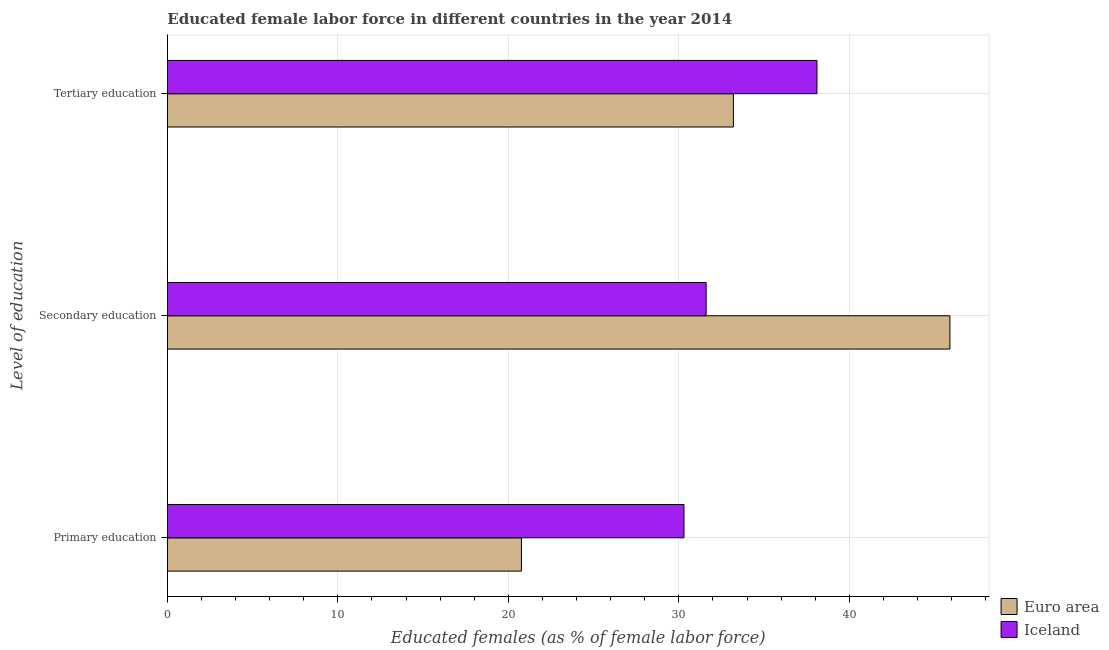How many different coloured bars are there?
Provide a short and direct response. 2. How many groups of bars are there?
Your answer should be compact. 3. How many bars are there on the 3rd tick from the bottom?
Ensure brevity in your answer.  2. What is the label of the 2nd group of bars from the top?
Offer a terse response. Secondary education. What is the percentage of female labor force who received secondary education in Iceland?
Your response must be concise. 31.6. Across all countries, what is the maximum percentage of female labor force who received tertiary education?
Keep it short and to the point. 38.1. Across all countries, what is the minimum percentage of female labor force who received primary education?
Make the answer very short. 20.77. In which country was the percentage of female labor force who received tertiary education minimum?
Make the answer very short. Euro area. What is the total percentage of female labor force who received secondary education in the graph?
Give a very brief answer. 77.5. What is the difference between the percentage of female labor force who received tertiary education in Iceland and that in Euro area?
Your answer should be very brief. 4.9. What is the difference between the percentage of female labor force who received primary education in Euro area and the percentage of female labor force who received tertiary education in Iceland?
Your response must be concise. -17.33. What is the average percentage of female labor force who received primary education per country?
Offer a very short reply. 25.53. What is the difference between the percentage of female labor force who received secondary education and percentage of female labor force who received tertiary education in Euro area?
Offer a very short reply. 12.7. What is the ratio of the percentage of female labor force who received primary education in Iceland to that in Euro area?
Keep it short and to the point. 1.46. What is the difference between the highest and the second highest percentage of female labor force who received secondary education?
Provide a short and direct response. 14.3. What is the difference between the highest and the lowest percentage of female labor force who received primary education?
Give a very brief answer. 9.53. In how many countries, is the percentage of female labor force who received tertiary education greater than the average percentage of female labor force who received tertiary education taken over all countries?
Your answer should be very brief. 1. What does the 2nd bar from the top in Primary education represents?
Make the answer very short. Euro area. What does the 2nd bar from the bottom in Tertiary education represents?
Offer a terse response. Iceland. Is it the case that in every country, the sum of the percentage of female labor force who received primary education and percentage of female labor force who received secondary education is greater than the percentage of female labor force who received tertiary education?
Your answer should be very brief. Yes. Are all the bars in the graph horizontal?
Provide a short and direct response. Yes. How many countries are there in the graph?
Give a very brief answer. 2. Does the graph contain grids?
Keep it short and to the point. Yes. How many legend labels are there?
Offer a very short reply. 2. What is the title of the graph?
Provide a succinct answer. Educated female labor force in different countries in the year 2014. What is the label or title of the X-axis?
Offer a very short reply. Educated females (as % of female labor force). What is the label or title of the Y-axis?
Offer a terse response. Level of education. What is the Educated females (as % of female labor force) in Euro area in Primary education?
Provide a short and direct response. 20.77. What is the Educated females (as % of female labor force) of Iceland in Primary education?
Keep it short and to the point. 30.3. What is the Educated females (as % of female labor force) of Euro area in Secondary education?
Provide a short and direct response. 45.9. What is the Educated females (as % of female labor force) of Iceland in Secondary education?
Give a very brief answer. 31.6. What is the Educated females (as % of female labor force) in Euro area in Tertiary education?
Your answer should be very brief. 33.2. What is the Educated females (as % of female labor force) of Iceland in Tertiary education?
Keep it short and to the point. 38.1. Across all Level of education, what is the maximum Educated females (as % of female labor force) in Euro area?
Your answer should be very brief. 45.9. Across all Level of education, what is the maximum Educated females (as % of female labor force) in Iceland?
Your answer should be compact. 38.1. Across all Level of education, what is the minimum Educated females (as % of female labor force) of Euro area?
Ensure brevity in your answer.  20.77. Across all Level of education, what is the minimum Educated females (as % of female labor force) of Iceland?
Give a very brief answer. 30.3. What is the total Educated females (as % of female labor force) in Euro area in the graph?
Keep it short and to the point. 99.87. What is the total Educated females (as % of female labor force) of Iceland in the graph?
Offer a terse response. 100. What is the difference between the Educated females (as % of female labor force) of Euro area in Primary education and that in Secondary education?
Your answer should be very brief. -25.13. What is the difference between the Educated females (as % of female labor force) of Euro area in Primary education and that in Tertiary education?
Give a very brief answer. -12.43. What is the difference between the Educated females (as % of female labor force) in Iceland in Primary education and that in Tertiary education?
Provide a succinct answer. -7.8. What is the difference between the Educated females (as % of female labor force) in Euro area in Secondary education and that in Tertiary education?
Ensure brevity in your answer.  12.7. What is the difference between the Educated females (as % of female labor force) of Iceland in Secondary education and that in Tertiary education?
Your response must be concise. -6.5. What is the difference between the Educated females (as % of female labor force) of Euro area in Primary education and the Educated females (as % of female labor force) of Iceland in Secondary education?
Provide a short and direct response. -10.83. What is the difference between the Educated females (as % of female labor force) in Euro area in Primary education and the Educated females (as % of female labor force) in Iceland in Tertiary education?
Provide a short and direct response. -17.33. What is the difference between the Educated females (as % of female labor force) in Euro area in Secondary education and the Educated females (as % of female labor force) in Iceland in Tertiary education?
Your answer should be very brief. 7.8. What is the average Educated females (as % of female labor force) of Euro area per Level of education?
Your answer should be very brief. 33.29. What is the average Educated females (as % of female labor force) of Iceland per Level of education?
Your answer should be compact. 33.33. What is the difference between the Educated females (as % of female labor force) of Euro area and Educated females (as % of female labor force) of Iceland in Primary education?
Provide a succinct answer. -9.53. What is the difference between the Educated females (as % of female labor force) of Euro area and Educated females (as % of female labor force) of Iceland in Secondary education?
Provide a short and direct response. 14.3. What is the difference between the Educated females (as % of female labor force) in Euro area and Educated females (as % of female labor force) in Iceland in Tertiary education?
Offer a terse response. -4.9. What is the ratio of the Educated females (as % of female labor force) of Euro area in Primary education to that in Secondary education?
Provide a short and direct response. 0.45. What is the ratio of the Educated females (as % of female labor force) of Iceland in Primary education to that in Secondary education?
Ensure brevity in your answer.  0.96. What is the ratio of the Educated females (as % of female labor force) of Euro area in Primary education to that in Tertiary education?
Ensure brevity in your answer.  0.63. What is the ratio of the Educated females (as % of female labor force) in Iceland in Primary education to that in Tertiary education?
Make the answer very short. 0.8. What is the ratio of the Educated females (as % of female labor force) of Euro area in Secondary education to that in Tertiary education?
Your response must be concise. 1.38. What is the ratio of the Educated females (as % of female labor force) of Iceland in Secondary education to that in Tertiary education?
Provide a short and direct response. 0.83. What is the difference between the highest and the second highest Educated females (as % of female labor force) in Euro area?
Provide a short and direct response. 12.7. What is the difference between the highest and the second highest Educated females (as % of female labor force) in Iceland?
Offer a very short reply. 6.5. What is the difference between the highest and the lowest Educated females (as % of female labor force) of Euro area?
Make the answer very short. 25.13. 